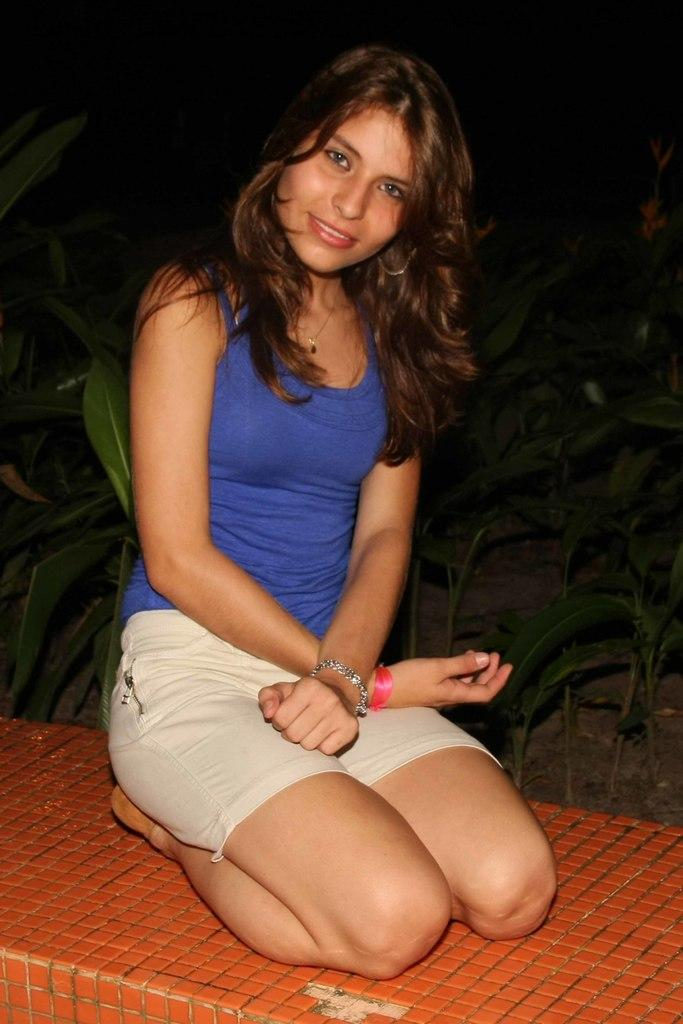Who is present in the image? There is a woman in the image. What is the woman doing in the image? The woman is kneeling on the floor. What is the woman's facial expression in the image? The woman is smiling. What can be seen in the background of the image? There are plants in the background of the image. How would you describe the lighting in the image? The background of the image is dark. Where is the bomb located in the image? There is no bomb present in the image. Is the woman wearing a crown in the image? No, the woman is not wearing a crown in the image. 